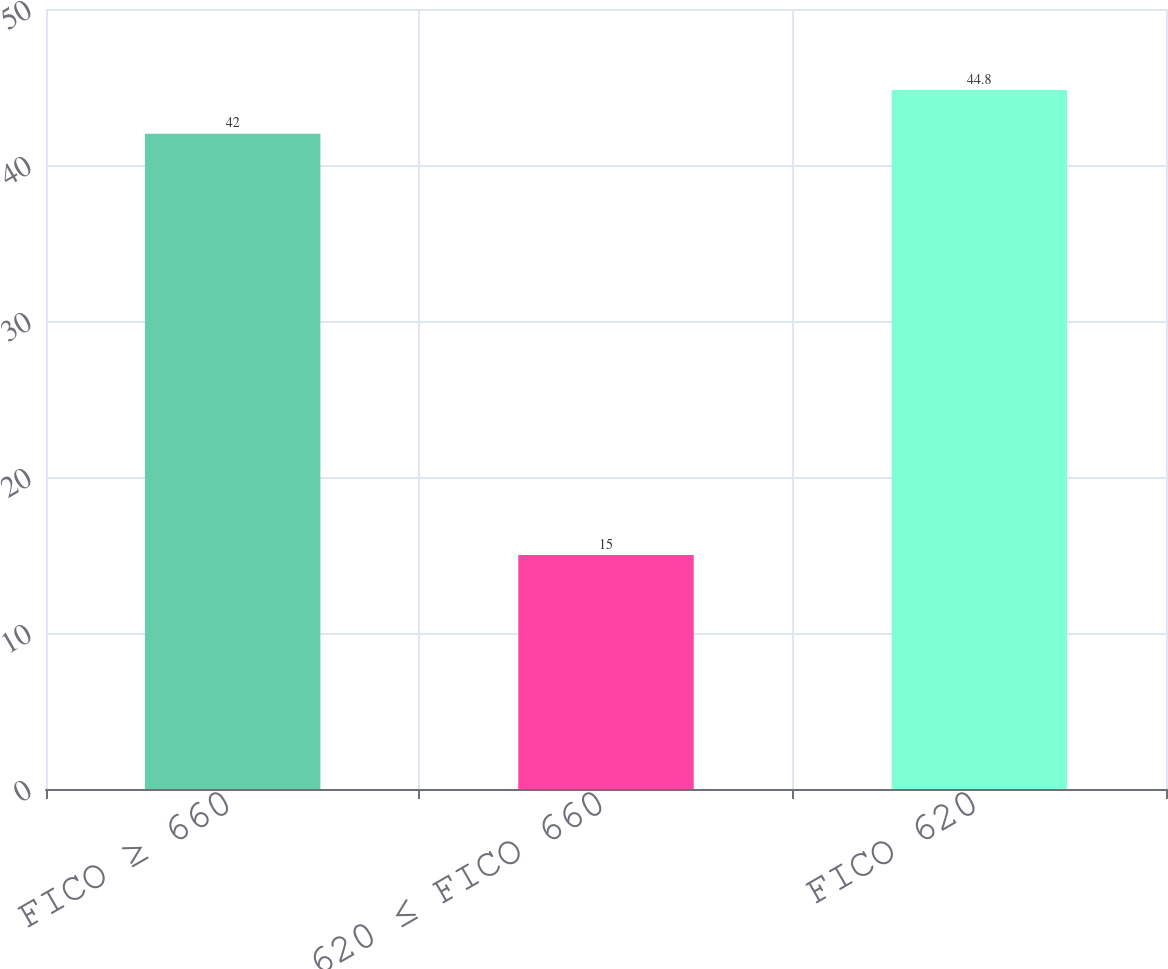Convert chart to OTSL. <chart><loc_0><loc_0><loc_500><loc_500><bar_chart><fcel>FICO ≥ 660<fcel>620 ≤ FICO 660<fcel>FICO 620<nl><fcel>42<fcel>15<fcel>44.8<nl></chart> 